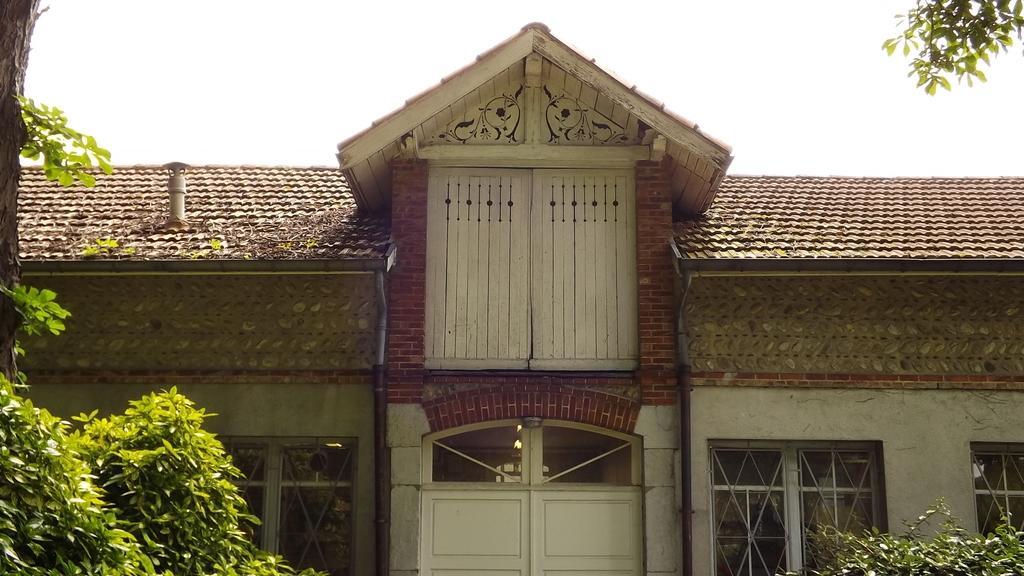Please provide a concise description of this image. This image is taken outdoors. At the top of the image there is the sky. In the middle of the image there is a house with walls, windows, a roof and a door. On the left and right sides of the image there are two trees and a few plants with leaves. 